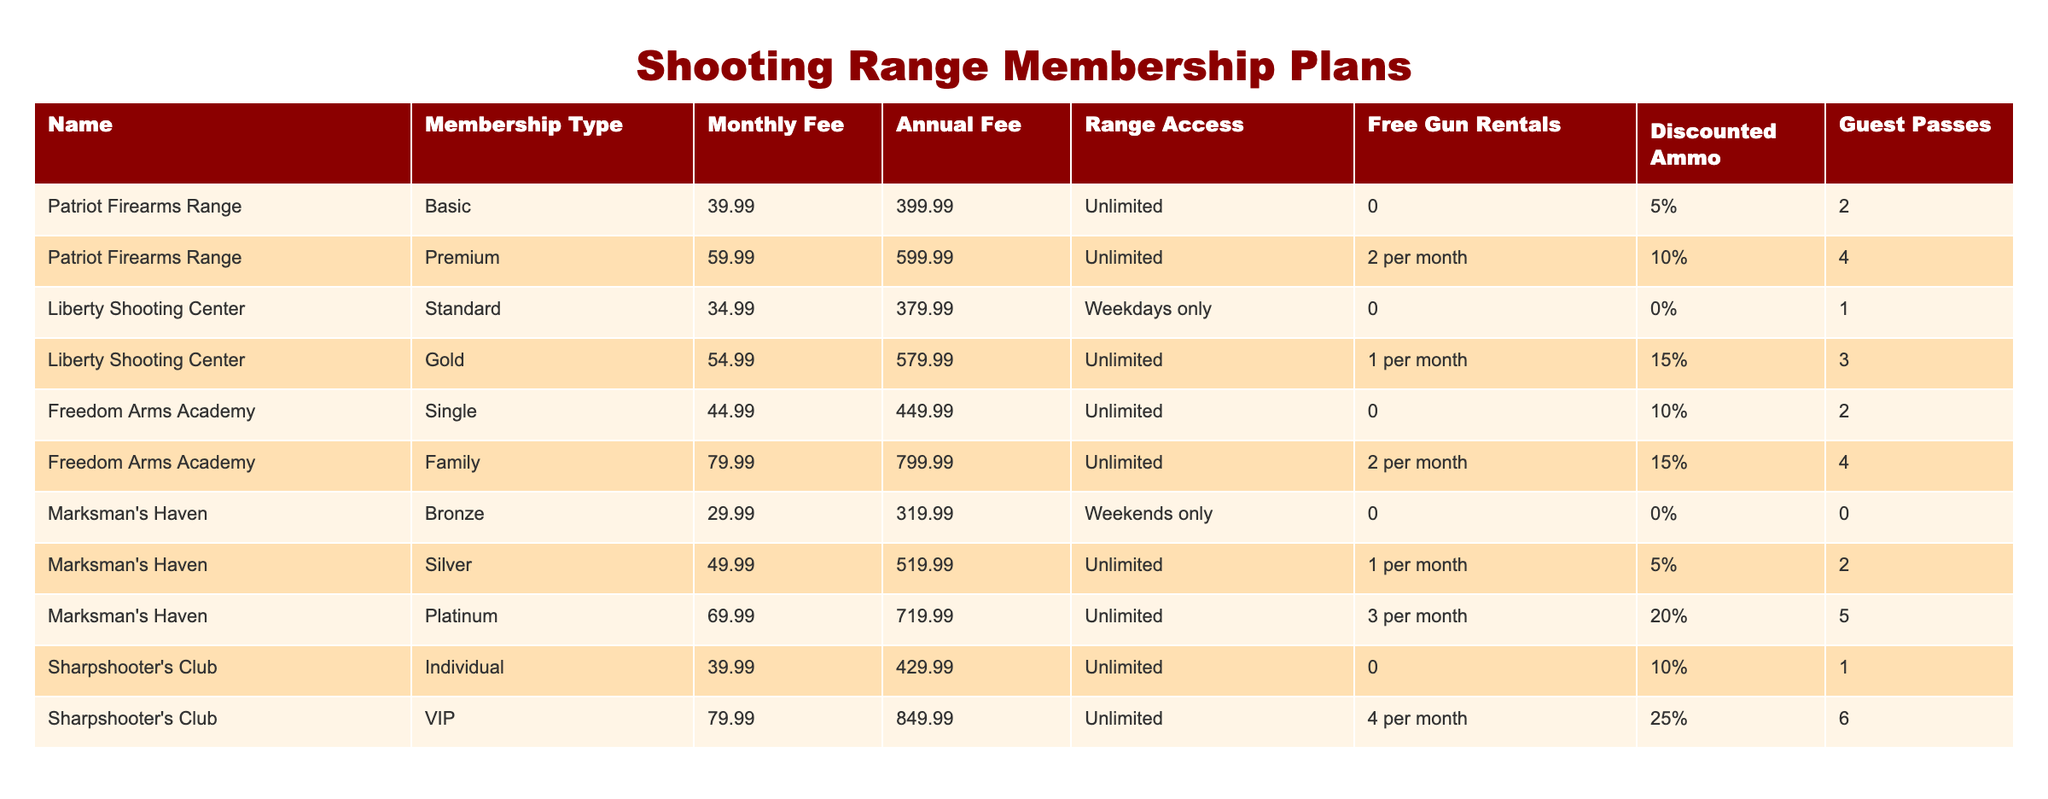What is the monthly fee for the Platinum membership at Marksman's Haven? The monthly fee for the Platinum membership is listed in the "Monthly Fee" column under "Marksman's Haven" for "Platinum," which shows the value of 69.99.
Answer: 69.99 How many guest passes do you get with a Basic membership at Patriot Firearms Range? The number of guest passes for the Basic membership at Patriot Firearms Range is shown in the "Guest Passes" column for "Basic," which indicates there are 2 guest passes.
Answer: 2 Which membership has the highest annual fee, and what is that fee? By reviewing the "Annual Fee" column for each membership plan, we find that the VIP membership at Sharpshooter's Club has the highest fee of 849.99.
Answer: VIP, 849.99 Does the Gold membership at Liberty Shooting Center offer free gun rentals? The "Free Gun Rentals" column for the Gold membership at Liberty Shooting Center states that it includes 1 rental per month, so it does not offer entirely free rentals.
Answer: No What is the difference in the annual fee between the Family membership at Freedom Arms Academy and the Silver membership at Marksman's Haven? To determine the difference, we subtract the annual fee of the Silver membership (519.99) from the Family membership (799.99): 799.99 - 519.99 = 280.00.
Answer: 280.00 Which membership type offers the most guest passes, and how many are included? By examining the "Guest Passes" column, the VIP membership at Sharpshooter's Club offers the most guest passes, totaling 6.
Answer: VIP, 6 What is the average monthly fee of all memberships that allow unlimited range access? Identify all memberships with unlimited range access: Basic, Premium, Gold, Silver, Platinum, Individual, and VIP. Calculate the sum: 39.99 + 59.99 + 54.99 + 49.99 + 69.99 + 39.99 + 79.99 = 393.93. There are 7 memberships, so the average is 393.93/7 ≈ 56.13.
Answer: 56.13 Which membership plan offers discounted ammo of 25%? Check the discounted ammo percentage in the table, which reveals only the VIP membership at Sharpshooter's Club offers a discount of 25%.
Answer: VIP, 25% Is the Family membership at Freedom Arms Academy the only plan that offers 4 guest passes? Looking at the "Guest Passes" column, only the Family membership at Freedom Arms Academy offers 4 guest passes; thus, it is indeed the only plan with this number.
Answer: Yes 